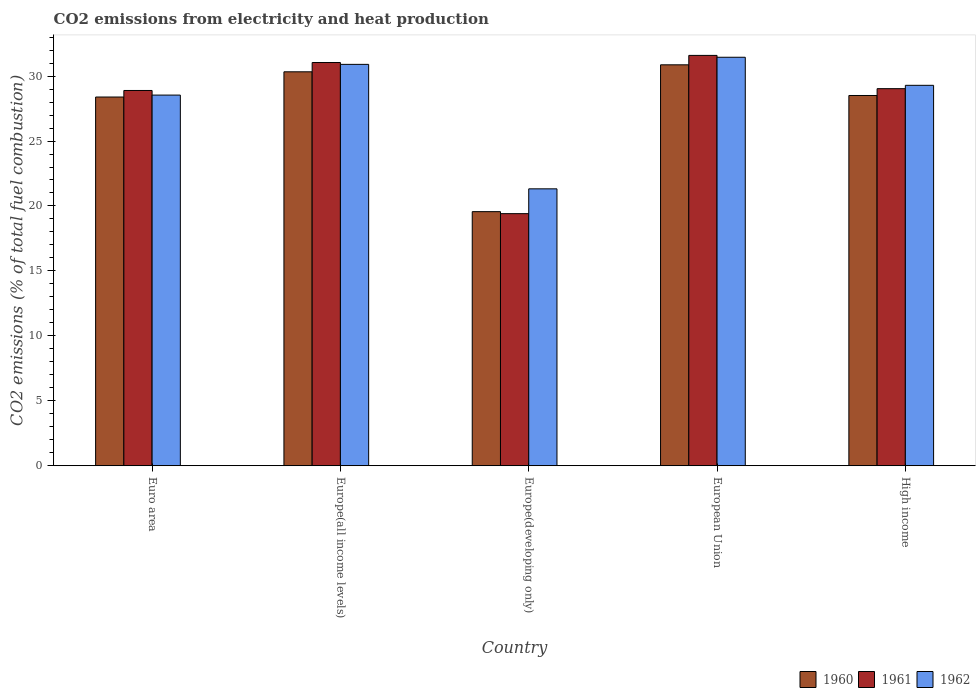How many different coloured bars are there?
Your answer should be compact. 3. Are the number of bars on each tick of the X-axis equal?
Keep it short and to the point. Yes. How many bars are there on the 3rd tick from the left?
Your answer should be very brief. 3. What is the label of the 1st group of bars from the left?
Your response must be concise. Euro area. In how many cases, is the number of bars for a given country not equal to the number of legend labels?
Offer a very short reply. 0. What is the amount of CO2 emitted in 1960 in Euro area?
Keep it short and to the point. 28.39. Across all countries, what is the maximum amount of CO2 emitted in 1962?
Give a very brief answer. 31.45. Across all countries, what is the minimum amount of CO2 emitted in 1961?
Your answer should be very brief. 19.41. In which country was the amount of CO2 emitted in 1962 maximum?
Provide a short and direct response. European Union. In which country was the amount of CO2 emitted in 1960 minimum?
Your response must be concise. Europe(developing only). What is the total amount of CO2 emitted in 1961 in the graph?
Keep it short and to the point. 139.97. What is the difference between the amount of CO2 emitted in 1961 in Europe(all income levels) and that in Europe(developing only)?
Offer a very short reply. 11.64. What is the difference between the amount of CO2 emitted in 1961 in High income and the amount of CO2 emitted in 1960 in European Union?
Give a very brief answer. -1.84. What is the average amount of CO2 emitted in 1961 per country?
Your answer should be compact. 27.99. What is the difference between the amount of CO2 emitted of/in 1961 and amount of CO2 emitted of/in 1960 in Euro area?
Provide a short and direct response. 0.5. In how many countries, is the amount of CO2 emitted in 1960 greater than 27 %?
Keep it short and to the point. 4. What is the ratio of the amount of CO2 emitted in 1961 in Euro area to that in High income?
Make the answer very short. 1. What is the difference between the highest and the second highest amount of CO2 emitted in 1962?
Your response must be concise. -1.61. What is the difference between the highest and the lowest amount of CO2 emitted in 1960?
Offer a terse response. 11.31. In how many countries, is the amount of CO2 emitted in 1961 greater than the average amount of CO2 emitted in 1961 taken over all countries?
Ensure brevity in your answer.  4. What does the 1st bar from the left in High income represents?
Offer a terse response. 1960. How many bars are there?
Provide a succinct answer. 15. Are all the bars in the graph horizontal?
Your response must be concise. No. How many countries are there in the graph?
Offer a terse response. 5. What is the difference between two consecutive major ticks on the Y-axis?
Ensure brevity in your answer.  5. Are the values on the major ticks of Y-axis written in scientific E-notation?
Your answer should be very brief. No. Does the graph contain any zero values?
Offer a very short reply. No. Does the graph contain grids?
Ensure brevity in your answer.  No. What is the title of the graph?
Your answer should be very brief. CO2 emissions from electricity and heat production. Does "1967" appear as one of the legend labels in the graph?
Your response must be concise. No. What is the label or title of the Y-axis?
Your answer should be very brief. CO2 emissions (% of total fuel combustion). What is the CO2 emissions (% of total fuel combustion) in 1960 in Euro area?
Your answer should be very brief. 28.39. What is the CO2 emissions (% of total fuel combustion) of 1961 in Euro area?
Your answer should be very brief. 28.89. What is the CO2 emissions (% of total fuel combustion) of 1962 in Euro area?
Provide a succinct answer. 28.54. What is the CO2 emissions (% of total fuel combustion) of 1960 in Europe(all income levels)?
Offer a terse response. 30.33. What is the CO2 emissions (% of total fuel combustion) of 1961 in Europe(all income levels)?
Ensure brevity in your answer.  31.04. What is the CO2 emissions (% of total fuel combustion) in 1962 in Europe(all income levels)?
Give a very brief answer. 30.9. What is the CO2 emissions (% of total fuel combustion) in 1960 in Europe(developing only)?
Make the answer very short. 19.56. What is the CO2 emissions (% of total fuel combustion) of 1961 in Europe(developing only)?
Ensure brevity in your answer.  19.41. What is the CO2 emissions (% of total fuel combustion) in 1962 in Europe(developing only)?
Your response must be concise. 21.32. What is the CO2 emissions (% of total fuel combustion) of 1960 in European Union?
Provide a succinct answer. 30.87. What is the CO2 emissions (% of total fuel combustion) in 1961 in European Union?
Ensure brevity in your answer.  31.59. What is the CO2 emissions (% of total fuel combustion) in 1962 in European Union?
Provide a short and direct response. 31.45. What is the CO2 emissions (% of total fuel combustion) in 1960 in High income?
Your answer should be very brief. 28.51. What is the CO2 emissions (% of total fuel combustion) of 1961 in High income?
Your answer should be very brief. 29.03. What is the CO2 emissions (% of total fuel combustion) in 1962 in High income?
Offer a very short reply. 29.29. Across all countries, what is the maximum CO2 emissions (% of total fuel combustion) of 1960?
Provide a short and direct response. 30.87. Across all countries, what is the maximum CO2 emissions (% of total fuel combustion) in 1961?
Make the answer very short. 31.59. Across all countries, what is the maximum CO2 emissions (% of total fuel combustion) of 1962?
Provide a short and direct response. 31.45. Across all countries, what is the minimum CO2 emissions (% of total fuel combustion) in 1960?
Offer a very short reply. 19.56. Across all countries, what is the minimum CO2 emissions (% of total fuel combustion) in 1961?
Provide a succinct answer. 19.41. Across all countries, what is the minimum CO2 emissions (% of total fuel combustion) in 1962?
Make the answer very short. 21.32. What is the total CO2 emissions (% of total fuel combustion) of 1960 in the graph?
Provide a short and direct response. 137.66. What is the total CO2 emissions (% of total fuel combustion) in 1961 in the graph?
Ensure brevity in your answer.  139.97. What is the total CO2 emissions (% of total fuel combustion) of 1962 in the graph?
Make the answer very short. 141.5. What is the difference between the CO2 emissions (% of total fuel combustion) of 1960 in Euro area and that in Europe(all income levels)?
Make the answer very short. -1.94. What is the difference between the CO2 emissions (% of total fuel combustion) of 1961 in Euro area and that in Europe(all income levels)?
Ensure brevity in your answer.  -2.15. What is the difference between the CO2 emissions (% of total fuel combustion) of 1962 in Euro area and that in Europe(all income levels)?
Keep it short and to the point. -2.37. What is the difference between the CO2 emissions (% of total fuel combustion) of 1960 in Euro area and that in Europe(developing only)?
Your answer should be compact. 8.83. What is the difference between the CO2 emissions (% of total fuel combustion) in 1961 in Euro area and that in Europe(developing only)?
Offer a very short reply. 9.48. What is the difference between the CO2 emissions (% of total fuel combustion) of 1962 in Euro area and that in Europe(developing only)?
Ensure brevity in your answer.  7.22. What is the difference between the CO2 emissions (% of total fuel combustion) of 1960 in Euro area and that in European Union?
Offer a very short reply. -2.48. What is the difference between the CO2 emissions (% of total fuel combustion) in 1961 in Euro area and that in European Union?
Your answer should be very brief. -2.7. What is the difference between the CO2 emissions (% of total fuel combustion) of 1962 in Euro area and that in European Union?
Offer a terse response. -2.91. What is the difference between the CO2 emissions (% of total fuel combustion) of 1960 in Euro area and that in High income?
Ensure brevity in your answer.  -0.12. What is the difference between the CO2 emissions (% of total fuel combustion) of 1961 in Euro area and that in High income?
Your answer should be compact. -0.14. What is the difference between the CO2 emissions (% of total fuel combustion) of 1962 in Euro area and that in High income?
Offer a terse response. -0.75. What is the difference between the CO2 emissions (% of total fuel combustion) of 1960 in Europe(all income levels) and that in Europe(developing only)?
Offer a terse response. 10.77. What is the difference between the CO2 emissions (% of total fuel combustion) of 1961 in Europe(all income levels) and that in Europe(developing only)?
Your answer should be compact. 11.64. What is the difference between the CO2 emissions (% of total fuel combustion) of 1962 in Europe(all income levels) and that in Europe(developing only)?
Ensure brevity in your answer.  9.58. What is the difference between the CO2 emissions (% of total fuel combustion) in 1960 in Europe(all income levels) and that in European Union?
Provide a succinct answer. -0.54. What is the difference between the CO2 emissions (% of total fuel combustion) of 1961 in Europe(all income levels) and that in European Union?
Ensure brevity in your answer.  -0.55. What is the difference between the CO2 emissions (% of total fuel combustion) of 1962 in Europe(all income levels) and that in European Union?
Your response must be concise. -0.55. What is the difference between the CO2 emissions (% of total fuel combustion) of 1960 in Europe(all income levels) and that in High income?
Provide a succinct answer. 1.82. What is the difference between the CO2 emissions (% of total fuel combustion) in 1961 in Europe(all income levels) and that in High income?
Your answer should be compact. 2.01. What is the difference between the CO2 emissions (% of total fuel combustion) of 1962 in Europe(all income levels) and that in High income?
Keep it short and to the point. 1.61. What is the difference between the CO2 emissions (% of total fuel combustion) of 1960 in Europe(developing only) and that in European Union?
Ensure brevity in your answer.  -11.31. What is the difference between the CO2 emissions (% of total fuel combustion) in 1961 in Europe(developing only) and that in European Union?
Keep it short and to the point. -12.19. What is the difference between the CO2 emissions (% of total fuel combustion) of 1962 in Europe(developing only) and that in European Union?
Offer a terse response. -10.13. What is the difference between the CO2 emissions (% of total fuel combustion) in 1960 in Europe(developing only) and that in High income?
Provide a succinct answer. -8.94. What is the difference between the CO2 emissions (% of total fuel combustion) in 1961 in Europe(developing only) and that in High income?
Give a very brief answer. -9.62. What is the difference between the CO2 emissions (% of total fuel combustion) of 1962 in Europe(developing only) and that in High income?
Make the answer very short. -7.97. What is the difference between the CO2 emissions (% of total fuel combustion) in 1960 in European Union and that in High income?
Ensure brevity in your answer.  2.36. What is the difference between the CO2 emissions (% of total fuel combustion) in 1961 in European Union and that in High income?
Your response must be concise. 2.56. What is the difference between the CO2 emissions (% of total fuel combustion) in 1962 in European Union and that in High income?
Give a very brief answer. 2.16. What is the difference between the CO2 emissions (% of total fuel combustion) of 1960 in Euro area and the CO2 emissions (% of total fuel combustion) of 1961 in Europe(all income levels)?
Your response must be concise. -2.66. What is the difference between the CO2 emissions (% of total fuel combustion) in 1960 in Euro area and the CO2 emissions (% of total fuel combustion) in 1962 in Europe(all income levels)?
Make the answer very short. -2.51. What is the difference between the CO2 emissions (% of total fuel combustion) in 1961 in Euro area and the CO2 emissions (% of total fuel combustion) in 1962 in Europe(all income levels)?
Keep it short and to the point. -2.01. What is the difference between the CO2 emissions (% of total fuel combustion) of 1960 in Euro area and the CO2 emissions (% of total fuel combustion) of 1961 in Europe(developing only)?
Provide a short and direct response. 8.98. What is the difference between the CO2 emissions (% of total fuel combustion) in 1960 in Euro area and the CO2 emissions (% of total fuel combustion) in 1962 in Europe(developing only)?
Give a very brief answer. 7.07. What is the difference between the CO2 emissions (% of total fuel combustion) in 1961 in Euro area and the CO2 emissions (% of total fuel combustion) in 1962 in Europe(developing only)?
Your response must be concise. 7.57. What is the difference between the CO2 emissions (% of total fuel combustion) in 1960 in Euro area and the CO2 emissions (% of total fuel combustion) in 1961 in European Union?
Your response must be concise. -3.21. What is the difference between the CO2 emissions (% of total fuel combustion) of 1960 in Euro area and the CO2 emissions (% of total fuel combustion) of 1962 in European Union?
Give a very brief answer. -3.06. What is the difference between the CO2 emissions (% of total fuel combustion) of 1961 in Euro area and the CO2 emissions (% of total fuel combustion) of 1962 in European Union?
Offer a very short reply. -2.56. What is the difference between the CO2 emissions (% of total fuel combustion) of 1960 in Euro area and the CO2 emissions (% of total fuel combustion) of 1961 in High income?
Make the answer very short. -0.64. What is the difference between the CO2 emissions (% of total fuel combustion) in 1960 in Euro area and the CO2 emissions (% of total fuel combustion) in 1962 in High income?
Offer a terse response. -0.9. What is the difference between the CO2 emissions (% of total fuel combustion) of 1961 in Euro area and the CO2 emissions (% of total fuel combustion) of 1962 in High income?
Provide a short and direct response. -0.4. What is the difference between the CO2 emissions (% of total fuel combustion) of 1960 in Europe(all income levels) and the CO2 emissions (% of total fuel combustion) of 1961 in Europe(developing only)?
Provide a short and direct response. 10.92. What is the difference between the CO2 emissions (% of total fuel combustion) of 1960 in Europe(all income levels) and the CO2 emissions (% of total fuel combustion) of 1962 in Europe(developing only)?
Your response must be concise. 9.01. What is the difference between the CO2 emissions (% of total fuel combustion) in 1961 in Europe(all income levels) and the CO2 emissions (% of total fuel combustion) in 1962 in Europe(developing only)?
Your response must be concise. 9.73. What is the difference between the CO2 emissions (% of total fuel combustion) of 1960 in Europe(all income levels) and the CO2 emissions (% of total fuel combustion) of 1961 in European Union?
Keep it short and to the point. -1.26. What is the difference between the CO2 emissions (% of total fuel combustion) of 1960 in Europe(all income levels) and the CO2 emissions (% of total fuel combustion) of 1962 in European Union?
Provide a short and direct response. -1.12. What is the difference between the CO2 emissions (% of total fuel combustion) in 1961 in Europe(all income levels) and the CO2 emissions (% of total fuel combustion) in 1962 in European Union?
Keep it short and to the point. -0.41. What is the difference between the CO2 emissions (% of total fuel combustion) in 1960 in Europe(all income levels) and the CO2 emissions (% of total fuel combustion) in 1961 in High income?
Give a very brief answer. 1.3. What is the difference between the CO2 emissions (% of total fuel combustion) in 1960 in Europe(all income levels) and the CO2 emissions (% of total fuel combustion) in 1962 in High income?
Give a very brief answer. 1.04. What is the difference between the CO2 emissions (% of total fuel combustion) of 1961 in Europe(all income levels) and the CO2 emissions (% of total fuel combustion) of 1962 in High income?
Your answer should be compact. 1.75. What is the difference between the CO2 emissions (% of total fuel combustion) in 1960 in Europe(developing only) and the CO2 emissions (% of total fuel combustion) in 1961 in European Union?
Make the answer very short. -12.03. What is the difference between the CO2 emissions (% of total fuel combustion) in 1960 in Europe(developing only) and the CO2 emissions (% of total fuel combustion) in 1962 in European Union?
Keep it short and to the point. -11.89. What is the difference between the CO2 emissions (% of total fuel combustion) of 1961 in Europe(developing only) and the CO2 emissions (% of total fuel combustion) of 1962 in European Union?
Your response must be concise. -12.04. What is the difference between the CO2 emissions (% of total fuel combustion) of 1960 in Europe(developing only) and the CO2 emissions (% of total fuel combustion) of 1961 in High income?
Offer a very short reply. -9.47. What is the difference between the CO2 emissions (% of total fuel combustion) of 1960 in Europe(developing only) and the CO2 emissions (% of total fuel combustion) of 1962 in High income?
Provide a succinct answer. -9.73. What is the difference between the CO2 emissions (% of total fuel combustion) in 1961 in Europe(developing only) and the CO2 emissions (% of total fuel combustion) in 1962 in High income?
Your answer should be compact. -9.88. What is the difference between the CO2 emissions (% of total fuel combustion) of 1960 in European Union and the CO2 emissions (% of total fuel combustion) of 1961 in High income?
Give a very brief answer. 1.84. What is the difference between the CO2 emissions (% of total fuel combustion) of 1960 in European Union and the CO2 emissions (% of total fuel combustion) of 1962 in High income?
Your answer should be very brief. 1.58. What is the difference between the CO2 emissions (% of total fuel combustion) in 1961 in European Union and the CO2 emissions (% of total fuel combustion) in 1962 in High income?
Your response must be concise. 2.3. What is the average CO2 emissions (% of total fuel combustion) in 1960 per country?
Your answer should be very brief. 27.53. What is the average CO2 emissions (% of total fuel combustion) in 1961 per country?
Provide a succinct answer. 27.99. What is the average CO2 emissions (% of total fuel combustion) in 1962 per country?
Keep it short and to the point. 28.3. What is the difference between the CO2 emissions (% of total fuel combustion) of 1960 and CO2 emissions (% of total fuel combustion) of 1961 in Euro area?
Offer a very short reply. -0.5. What is the difference between the CO2 emissions (% of total fuel combustion) in 1960 and CO2 emissions (% of total fuel combustion) in 1962 in Euro area?
Your answer should be very brief. -0.15. What is the difference between the CO2 emissions (% of total fuel combustion) in 1961 and CO2 emissions (% of total fuel combustion) in 1962 in Euro area?
Your answer should be compact. 0.36. What is the difference between the CO2 emissions (% of total fuel combustion) in 1960 and CO2 emissions (% of total fuel combustion) in 1961 in Europe(all income levels)?
Provide a short and direct response. -0.71. What is the difference between the CO2 emissions (% of total fuel combustion) in 1960 and CO2 emissions (% of total fuel combustion) in 1962 in Europe(all income levels)?
Make the answer very short. -0.57. What is the difference between the CO2 emissions (% of total fuel combustion) in 1961 and CO2 emissions (% of total fuel combustion) in 1962 in Europe(all income levels)?
Make the answer very short. 0.14. What is the difference between the CO2 emissions (% of total fuel combustion) in 1960 and CO2 emissions (% of total fuel combustion) in 1961 in Europe(developing only)?
Offer a very short reply. 0.15. What is the difference between the CO2 emissions (% of total fuel combustion) in 1960 and CO2 emissions (% of total fuel combustion) in 1962 in Europe(developing only)?
Give a very brief answer. -1.76. What is the difference between the CO2 emissions (% of total fuel combustion) in 1961 and CO2 emissions (% of total fuel combustion) in 1962 in Europe(developing only)?
Provide a short and direct response. -1.91. What is the difference between the CO2 emissions (% of total fuel combustion) of 1960 and CO2 emissions (% of total fuel combustion) of 1961 in European Union?
Your response must be concise. -0.73. What is the difference between the CO2 emissions (% of total fuel combustion) in 1960 and CO2 emissions (% of total fuel combustion) in 1962 in European Union?
Offer a very short reply. -0.58. What is the difference between the CO2 emissions (% of total fuel combustion) of 1961 and CO2 emissions (% of total fuel combustion) of 1962 in European Union?
Offer a terse response. 0.14. What is the difference between the CO2 emissions (% of total fuel combustion) in 1960 and CO2 emissions (% of total fuel combustion) in 1961 in High income?
Make the answer very short. -0.53. What is the difference between the CO2 emissions (% of total fuel combustion) in 1960 and CO2 emissions (% of total fuel combustion) in 1962 in High income?
Your response must be concise. -0.78. What is the difference between the CO2 emissions (% of total fuel combustion) in 1961 and CO2 emissions (% of total fuel combustion) in 1962 in High income?
Provide a short and direct response. -0.26. What is the ratio of the CO2 emissions (% of total fuel combustion) in 1960 in Euro area to that in Europe(all income levels)?
Ensure brevity in your answer.  0.94. What is the ratio of the CO2 emissions (% of total fuel combustion) in 1961 in Euro area to that in Europe(all income levels)?
Provide a succinct answer. 0.93. What is the ratio of the CO2 emissions (% of total fuel combustion) of 1962 in Euro area to that in Europe(all income levels)?
Ensure brevity in your answer.  0.92. What is the ratio of the CO2 emissions (% of total fuel combustion) of 1960 in Euro area to that in Europe(developing only)?
Your answer should be very brief. 1.45. What is the ratio of the CO2 emissions (% of total fuel combustion) of 1961 in Euro area to that in Europe(developing only)?
Give a very brief answer. 1.49. What is the ratio of the CO2 emissions (% of total fuel combustion) of 1962 in Euro area to that in Europe(developing only)?
Make the answer very short. 1.34. What is the ratio of the CO2 emissions (% of total fuel combustion) in 1960 in Euro area to that in European Union?
Your answer should be very brief. 0.92. What is the ratio of the CO2 emissions (% of total fuel combustion) in 1961 in Euro area to that in European Union?
Keep it short and to the point. 0.91. What is the ratio of the CO2 emissions (% of total fuel combustion) in 1962 in Euro area to that in European Union?
Keep it short and to the point. 0.91. What is the ratio of the CO2 emissions (% of total fuel combustion) in 1960 in Euro area to that in High income?
Your answer should be very brief. 1. What is the ratio of the CO2 emissions (% of total fuel combustion) in 1961 in Euro area to that in High income?
Provide a short and direct response. 1. What is the ratio of the CO2 emissions (% of total fuel combustion) in 1962 in Euro area to that in High income?
Provide a short and direct response. 0.97. What is the ratio of the CO2 emissions (% of total fuel combustion) in 1960 in Europe(all income levels) to that in Europe(developing only)?
Your response must be concise. 1.55. What is the ratio of the CO2 emissions (% of total fuel combustion) of 1961 in Europe(all income levels) to that in Europe(developing only)?
Keep it short and to the point. 1.6. What is the ratio of the CO2 emissions (% of total fuel combustion) of 1962 in Europe(all income levels) to that in Europe(developing only)?
Your answer should be very brief. 1.45. What is the ratio of the CO2 emissions (% of total fuel combustion) in 1960 in Europe(all income levels) to that in European Union?
Provide a short and direct response. 0.98. What is the ratio of the CO2 emissions (% of total fuel combustion) of 1961 in Europe(all income levels) to that in European Union?
Your response must be concise. 0.98. What is the ratio of the CO2 emissions (% of total fuel combustion) of 1962 in Europe(all income levels) to that in European Union?
Offer a terse response. 0.98. What is the ratio of the CO2 emissions (% of total fuel combustion) of 1960 in Europe(all income levels) to that in High income?
Your answer should be compact. 1.06. What is the ratio of the CO2 emissions (% of total fuel combustion) in 1961 in Europe(all income levels) to that in High income?
Offer a very short reply. 1.07. What is the ratio of the CO2 emissions (% of total fuel combustion) of 1962 in Europe(all income levels) to that in High income?
Your answer should be very brief. 1.06. What is the ratio of the CO2 emissions (% of total fuel combustion) of 1960 in Europe(developing only) to that in European Union?
Give a very brief answer. 0.63. What is the ratio of the CO2 emissions (% of total fuel combustion) in 1961 in Europe(developing only) to that in European Union?
Provide a succinct answer. 0.61. What is the ratio of the CO2 emissions (% of total fuel combustion) of 1962 in Europe(developing only) to that in European Union?
Your answer should be very brief. 0.68. What is the ratio of the CO2 emissions (% of total fuel combustion) of 1960 in Europe(developing only) to that in High income?
Provide a short and direct response. 0.69. What is the ratio of the CO2 emissions (% of total fuel combustion) in 1961 in Europe(developing only) to that in High income?
Ensure brevity in your answer.  0.67. What is the ratio of the CO2 emissions (% of total fuel combustion) of 1962 in Europe(developing only) to that in High income?
Your answer should be very brief. 0.73. What is the ratio of the CO2 emissions (% of total fuel combustion) in 1960 in European Union to that in High income?
Make the answer very short. 1.08. What is the ratio of the CO2 emissions (% of total fuel combustion) of 1961 in European Union to that in High income?
Make the answer very short. 1.09. What is the ratio of the CO2 emissions (% of total fuel combustion) of 1962 in European Union to that in High income?
Your response must be concise. 1.07. What is the difference between the highest and the second highest CO2 emissions (% of total fuel combustion) of 1960?
Offer a very short reply. 0.54. What is the difference between the highest and the second highest CO2 emissions (% of total fuel combustion) in 1961?
Keep it short and to the point. 0.55. What is the difference between the highest and the second highest CO2 emissions (% of total fuel combustion) of 1962?
Ensure brevity in your answer.  0.55. What is the difference between the highest and the lowest CO2 emissions (% of total fuel combustion) in 1960?
Provide a short and direct response. 11.31. What is the difference between the highest and the lowest CO2 emissions (% of total fuel combustion) of 1961?
Provide a succinct answer. 12.19. What is the difference between the highest and the lowest CO2 emissions (% of total fuel combustion) in 1962?
Provide a short and direct response. 10.13. 